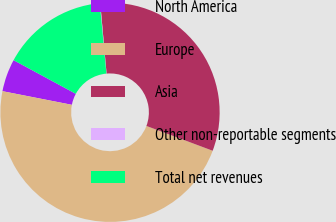Convert chart to OTSL. <chart><loc_0><loc_0><loc_500><loc_500><pie_chart><fcel>North America<fcel>Europe<fcel>Asia<fcel>Other non-reportable segments<fcel>Total net revenues<nl><fcel>4.8%<fcel>47.38%<fcel>32.12%<fcel>0.07%<fcel>15.62%<nl></chart> 